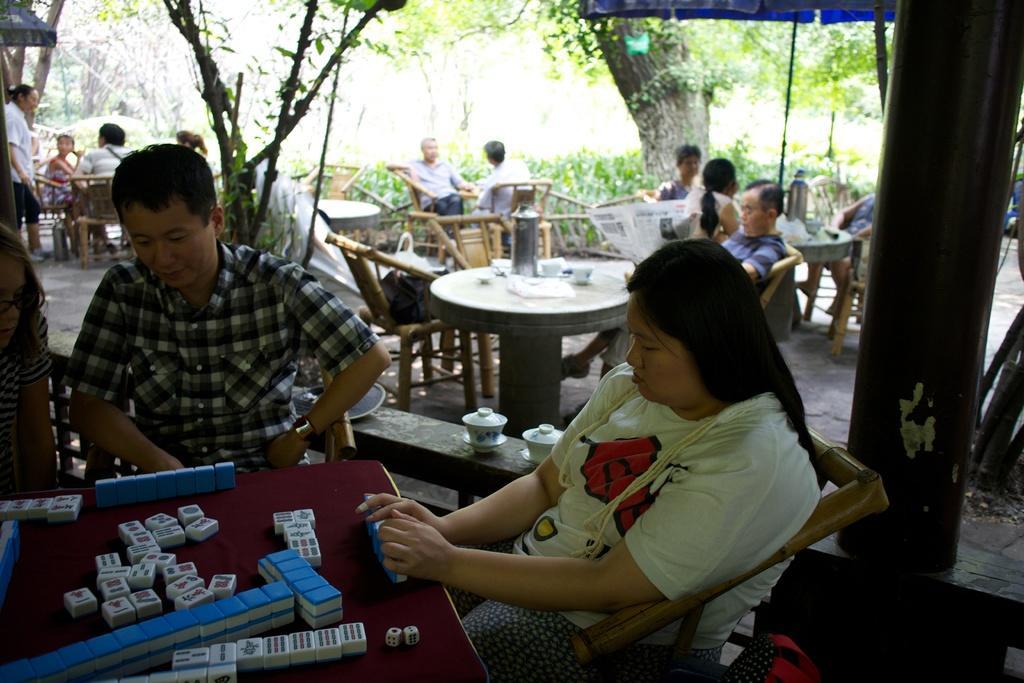In one or two sentences, can you explain what this image depicts? It is an outdoor picture where so many people are sitting in the chairs and at the right corner of the picture one woman is sitting on the chair and in yellow t-shirt and in front of the table and another person wearing a black and white shirt they are playing games on the table and behind them there is a table with cups and flask on it and there are so many trees in the background and in the right corner of the picture one person is standing in white shirt and behind him there is an umbrella in blue colour and to the very right corner of the picture there is a table with an umbrella in blue colour too. 